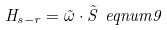Convert formula to latex. <formula><loc_0><loc_0><loc_500><loc_500>H _ { s - r } = \vec { \omega } \cdot \vec { S } \ e q n u m { 9 }</formula> 